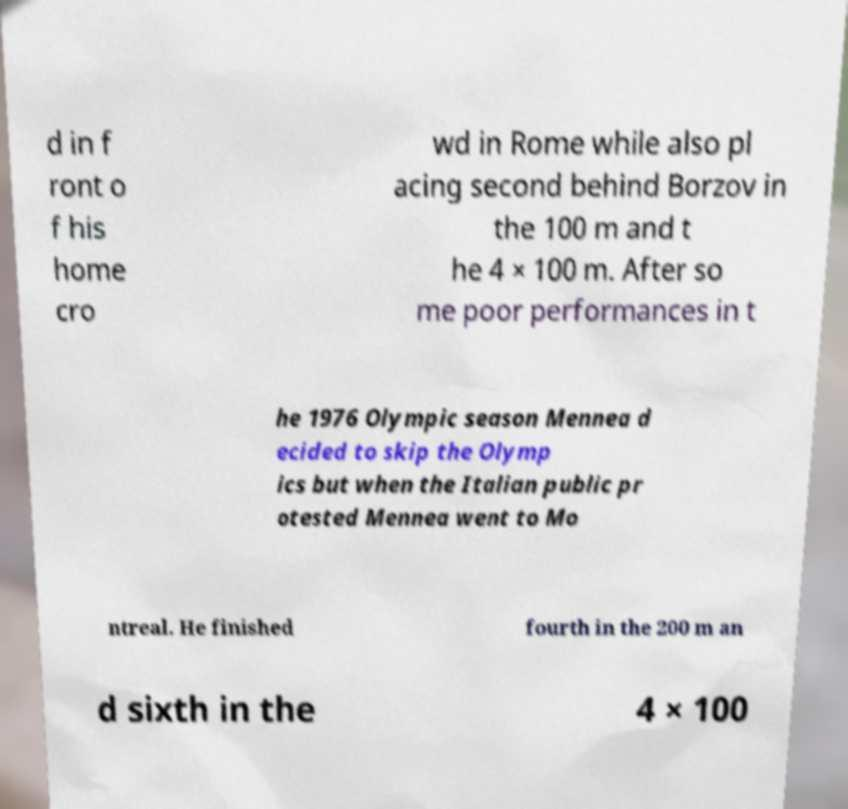Can you read and provide the text displayed in the image?This photo seems to have some interesting text. Can you extract and type it out for me? d in f ront o f his home cro wd in Rome while also pl acing second behind Borzov in the 100 m and t he 4 × 100 m. After so me poor performances in t he 1976 Olympic season Mennea d ecided to skip the Olymp ics but when the Italian public pr otested Mennea went to Mo ntreal. He finished fourth in the 200 m an d sixth in the 4 × 100 